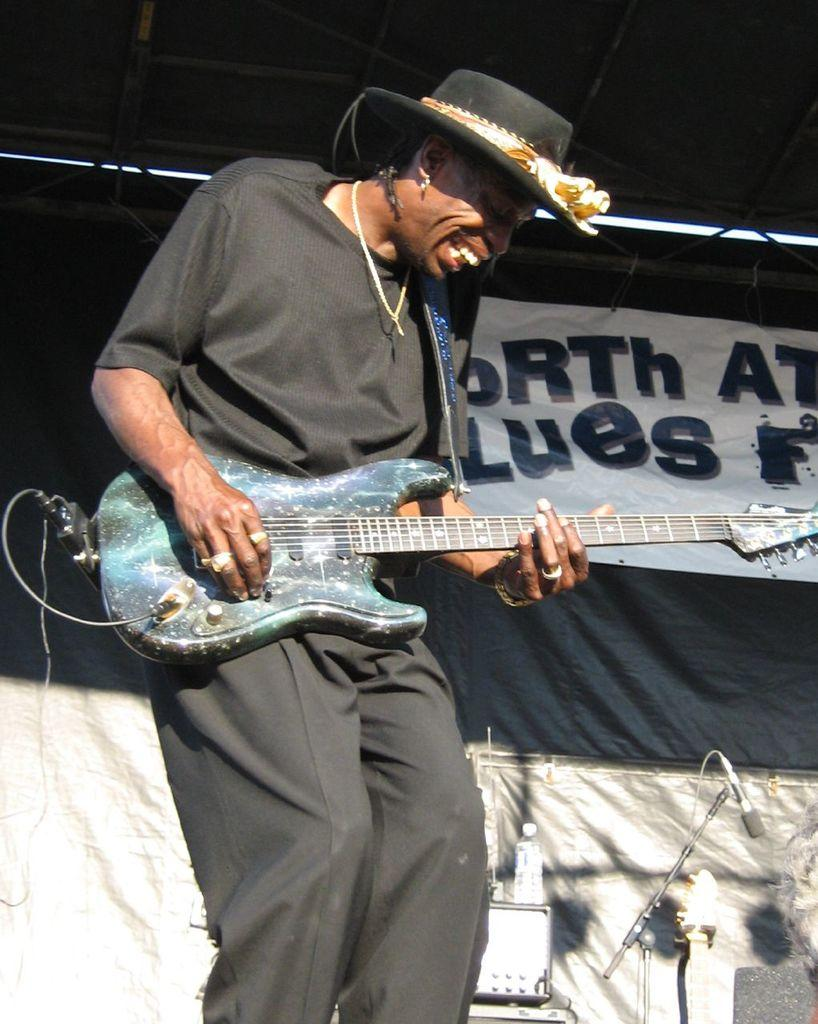Who is the main subject in the image? There is a woman in the image. What is the woman holding in the image? The woman is holding a guitar. What can be seen in the background of the image? There is a banner in the background of the image. What type of arithmetic problem is the woman solving in the image? There is no arithmetic problem present in the image; the woman is holding a guitar. 